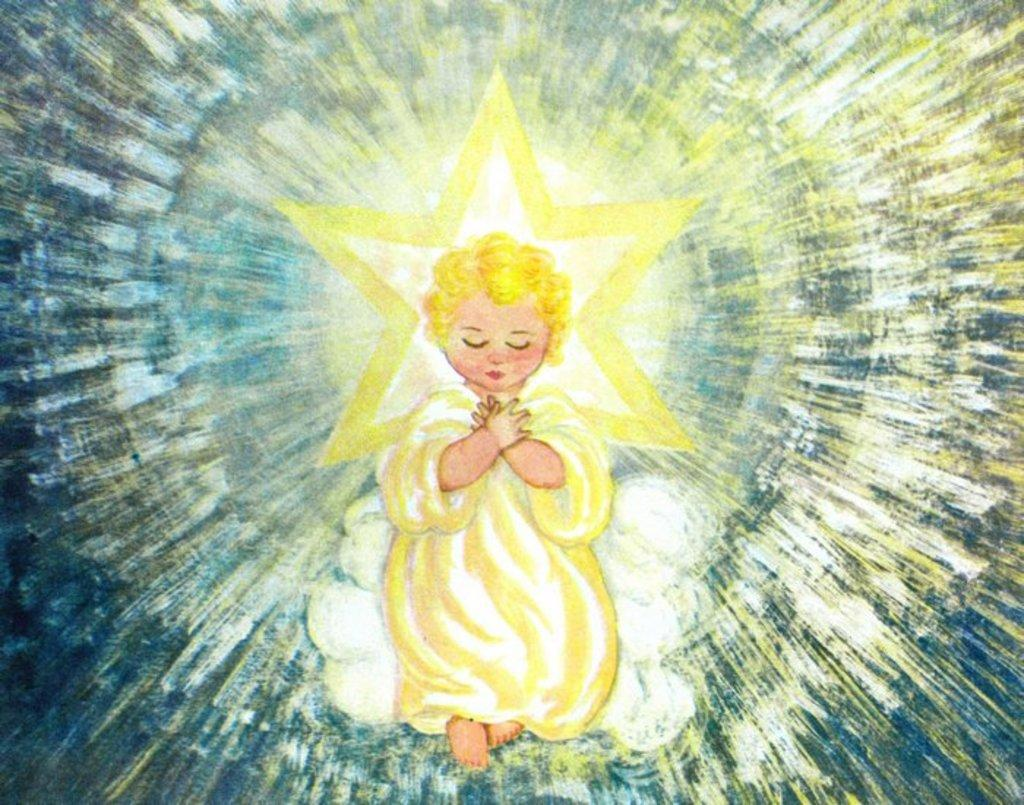What type of artwork is depicted in the image? The image is a painting. What is the main subject of the painting? There is a girl sitting in the center of the image. What can be seen in the background of the painting? There are sun rays visible in the background of the image. What type of attempt is the girl making with her partner in the image? There is no partner present in the image, and no attempt can be observed. Can you tell me how many toads are visible in the image? There are no toads present in the image. 